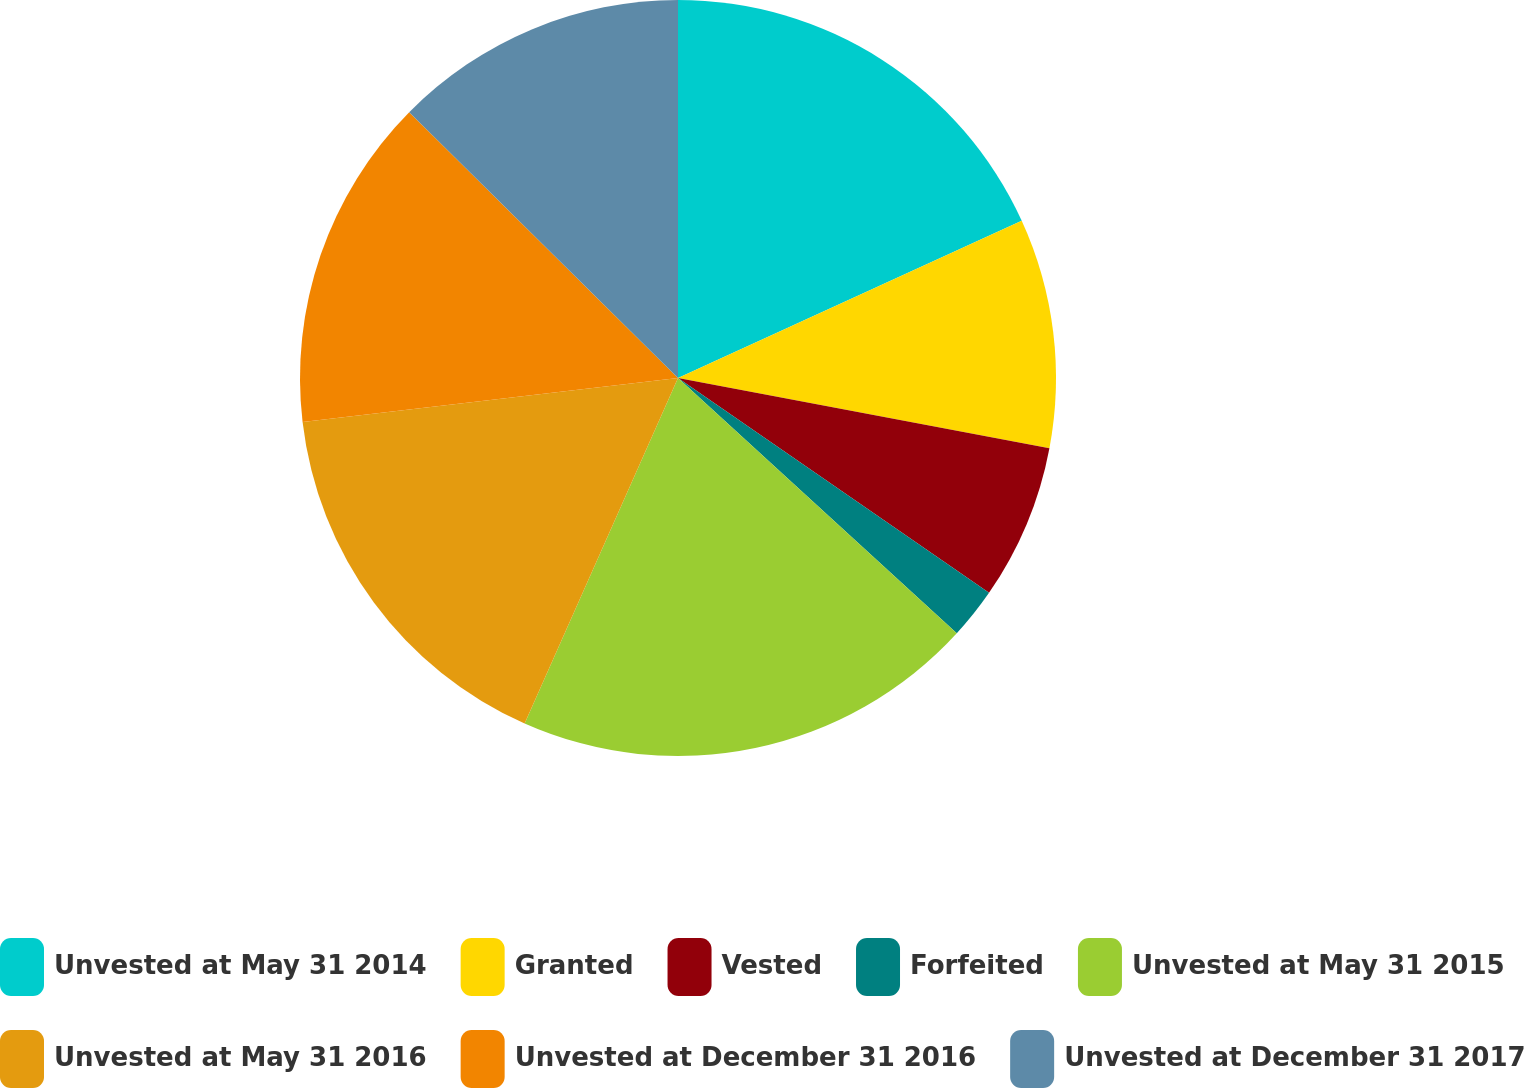<chart> <loc_0><loc_0><loc_500><loc_500><pie_chart><fcel>Unvested at May 31 2014<fcel>Granted<fcel>Vested<fcel>Forfeited<fcel>Unvested at May 31 2015<fcel>Unvested at May 31 2016<fcel>Unvested at December 31 2016<fcel>Unvested at December 31 2017<nl><fcel>18.17%<fcel>9.8%<fcel>6.65%<fcel>2.18%<fcel>19.85%<fcel>16.49%<fcel>14.27%<fcel>12.59%<nl></chart> 